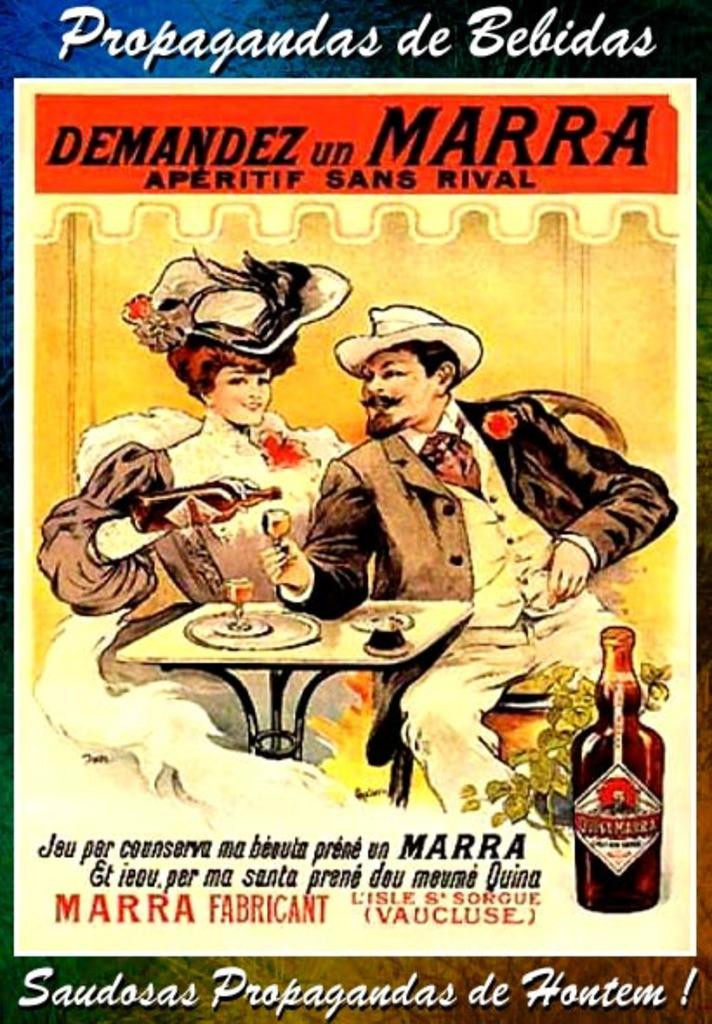What is the main subject in the center of the image? There is a poster in the center of the image. What can be seen on the poster? The poster contains depictions of a man and a woman. Where is the spot on the poster that the pan is placed on the lip? There is no spot, pan, or lip present on the poster in the image. 